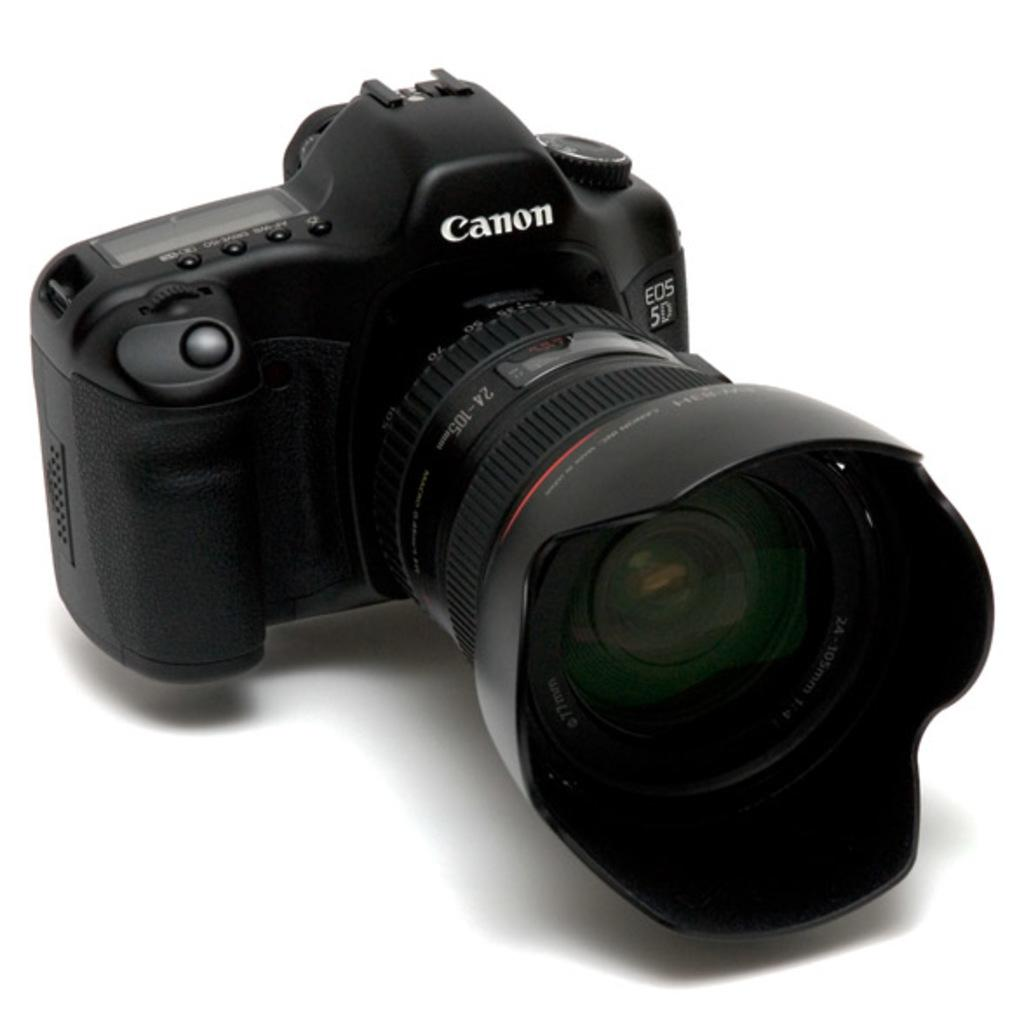What object is the main focus of the image? There is a camera in the image. Where is the camera located in the image? The camera is placed on a surface. What type of fuel does the camera use in the image? The image does not provide information about the camera's fuel source, as cameras typically do not require fuel. 